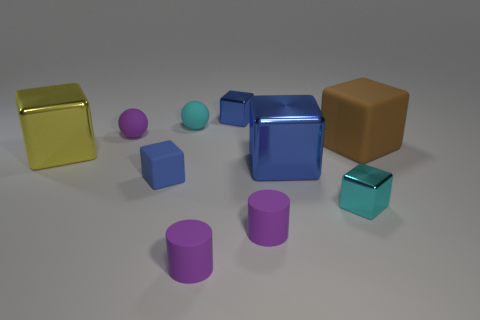What size is the matte cube on the right side of the small metal thing in front of the large brown rubber object?
Provide a succinct answer. Large. How many small things are cyan objects or blue metal objects?
Keep it short and to the point. 3. What number of other objects are there of the same color as the large matte object?
Keep it short and to the point. 0. There is a ball to the left of the small cyan sphere; is its size the same as the cyan thing to the left of the cyan metal object?
Provide a short and direct response. Yes. Is the brown thing made of the same material as the small blue thing behind the yellow object?
Keep it short and to the point. No. Are there more large brown matte blocks that are to the left of the big yellow thing than spheres that are to the right of the tiny cyan rubber ball?
Keep it short and to the point. No. There is a tiny metallic cube to the left of the cyan object that is in front of the yellow block; what color is it?
Your answer should be compact. Blue. What number of cubes are purple rubber objects or tiny metallic objects?
Offer a terse response. 2. What number of blue cubes are right of the tiny cyan rubber thing and in front of the small cyan matte thing?
Provide a succinct answer. 1. What is the color of the small metal object that is to the left of the tiny cyan metallic thing?
Ensure brevity in your answer.  Blue. 